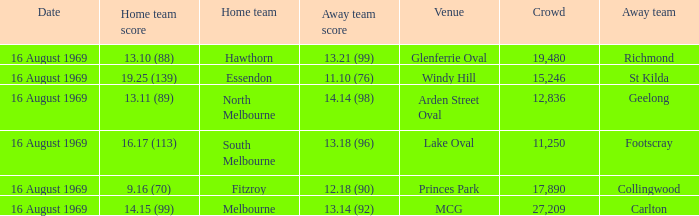Who was home at Princes Park? 9.16 (70). 